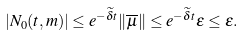Convert formula to latex. <formula><loc_0><loc_0><loc_500><loc_500>| N _ { 0 } ( t , m ) | \leq e ^ { - \widetilde { \delta } t } \| \overline { \mu } \| \leq e ^ { - \widetilde { \delta } t } \varepsilon \leq \varepsilon .</formula> 